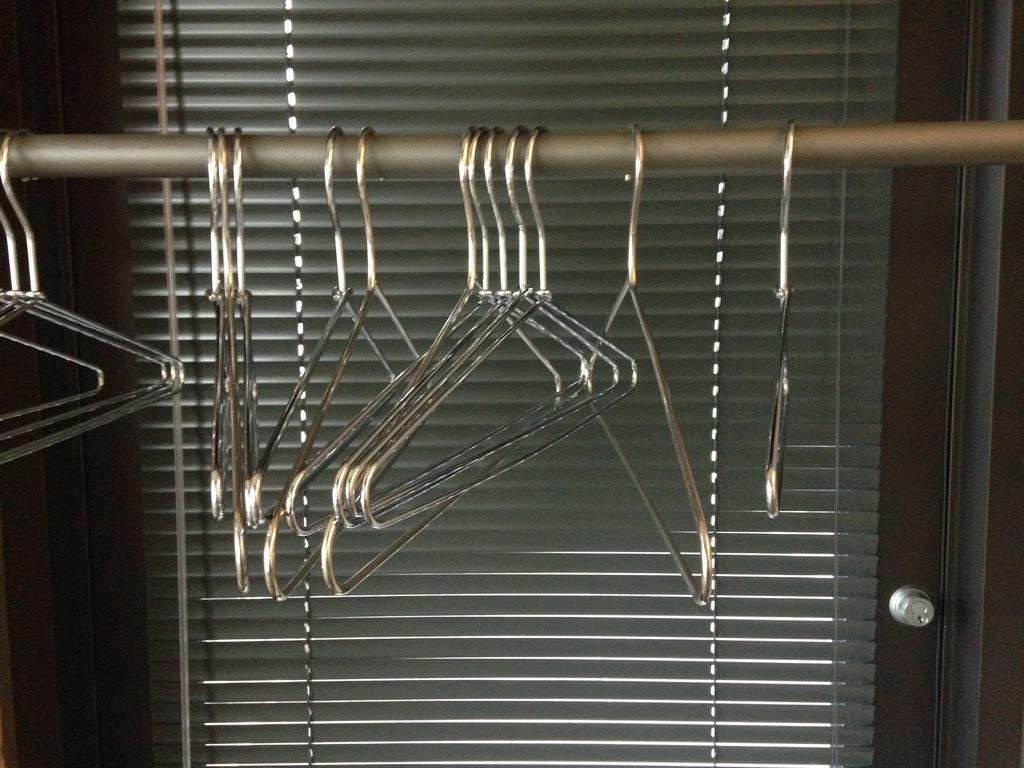Could you give a brief overview of what you see in this image? In this image we can see few hangers on a rod. Behind the hangers we can see the door. 